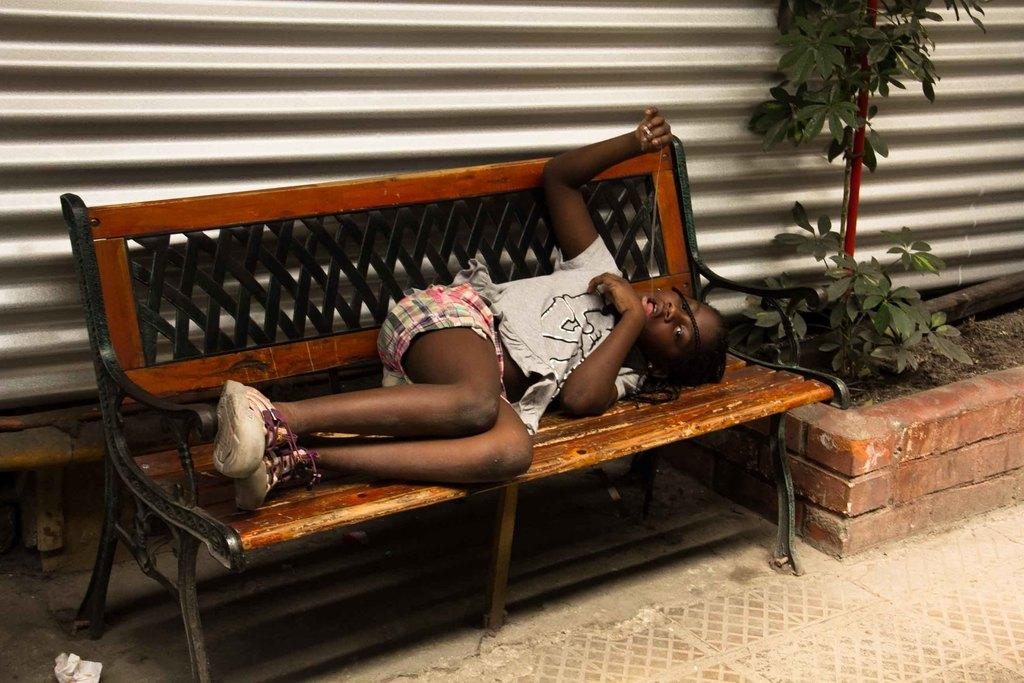Who is the main subject in the image? There is a girl in the image. What is the girl doing in the image? The girl is sleeping on a bench. What object is located behind the bench? There is a sweater behind the bench. What type of vegetation can be seen in the image? There is a plant on the right side of the image. What type of work is the girl doing in the image? The girl is not working in the image; she is sleeping on a bench. What color is the sky in the image? The provided facts do not mention the sky, so we cannot determine its color from the image. 